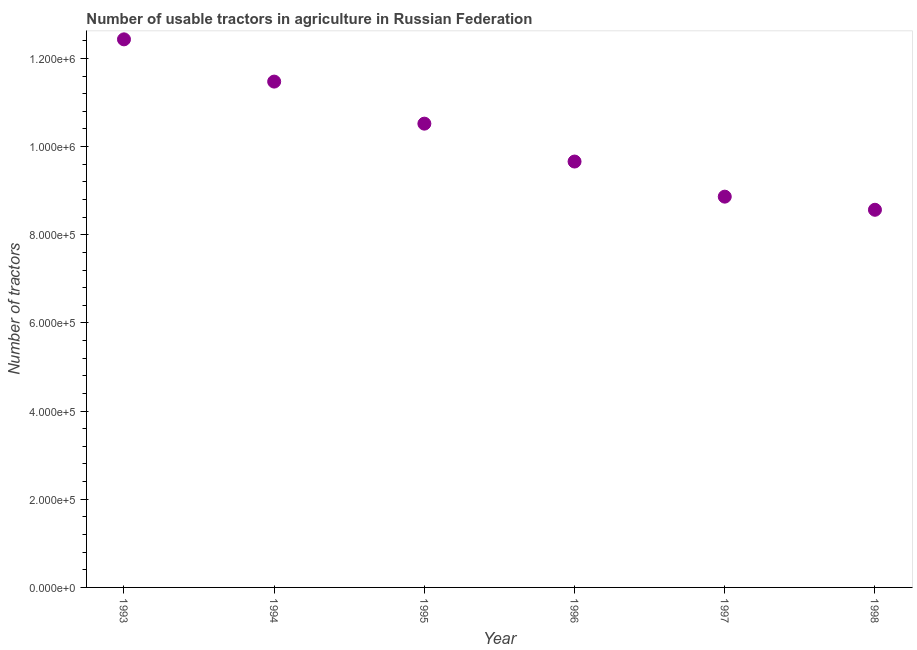What is the number of tractors in 1998?
Provide a short and direct response. 8.57e+05. Across all years, what is the maximum number of tractors?
Make the answer very short. 1.24e+06. Across all years, what is the minimum number of tractors?
Your answer should be compact. 8.57e+05. In which year was the number of tractors maximum?
Your answer should be compact. 1993. What is the sum of the number of tractors?
Your answer should be compact. 6.15e+06. What is the difference between the number of tractors in 1994 and 1997?
Ensure brevity in your answer.  2.61e+05. What is the average number of tractors per year?
Offer a very short reply. 1.03e+06. What is the median number of tractors?
Offer a terse response. 1.01e+06. Do a majority of the years between 1996 and 1998 (inclusive) have number of tractors greater than 480000 ?
Keep it short and to the point. Yes. What is the ratio of the number of tractors in 1993 to that in 1995?
Provide a short and direct response. 1.18. What is the difference between the highest and the second highest number of tractors?
Offer a terse response. 9.58e+04. What is the difference between the highest and the lowest number of tractors?
Offer a terse response. 3.87e+05. Does the number of tractors monotonically increase over the years?
Ensure brevity in your answer.  No. How many dotlines are there?
Your response must be concise. 1. How many years are there in the graph?
Give a very brief answer. 6. What is the difference between two consecutive major ticks on the Y-axis?
Offer a very short reply. 2.00e+05. What is the title of the graph?
Give a very brief answer. Number of usable tractors in agriculture in Russian Federation. What is the label or title of the X-axis?
Your response must be concise. Year. What is the label or title of the Y-axis?
Offer a very short reply. Number of tractors. What is the Number of tractors in 1993?
Provide a short and direct response. 1.24e+06. What is the Number of tractors in 1994?
Your response must be concise. 1.15e+06. What is the Number of tractors in 1995?
Offer a very short reply. 1.05e+06. What is the Number of tractors in 1996?
Give a very brief answer. 9.66e+05. What is the Number of tractors in 1997?
Your answer should be compact. 8.86e+05. What is the Number of tractors in 1998?
Provide a succinct answer. 8.57e+05. What is the difference between the Number of tractors in 1993 and 1994?
Provide a succinct answer. 9.58e+04. What is the difference between the Number of tractors in 1993 and 1995?
Make the answer very short. 1.91e+05. What is the difference between the Number of tractors in 1993 and 1996?
Your answer should be very brief. 2.77e+05. What is the difference between the Number of tractors in 1993 and 1997?
Your answer should be compact. 3.57e+05. What is the difference between the Number of tractors in 1993 and 1998?
Your answer should be compact. 3.87e+05. What is the difference between the Number of tractors in 1994 and 1995?
Make the answer very short. 9.54e+04. What is the difference between the Number of tractors in 1994 and 1996?
Your response must be concise. 1.81e+05. What is the difference between the Number of tractors in 1994 and 1997?
Your response must be concise. 2.61e+05. What is the difference between the Number of tractors in 1994 and 1998?
Make the answer very short. 2.91e+05. What is the difference between the Number of tractors in 1995 and 1996?
Your response must be concise. 8.60e+04. What is the difference between the Number of tractors in 1995 and 1997?
Provide a succinct answer. 1.66e+05. What is the difference between the Number of tractors in 1995 and 1998?
Your response must be concise. 1.95e+05. What is the difference between the Number of tractors in 1996 and 1997?
Your answer should be very brief. 7.96e+04. What is the difference between the Number of tractors in 1996 and 1998?
Your response must be concise. 1.09e+05. What is the difference between the Number of tractors in 1997 and 1998?
Make the answer very short. 2.98e+04. What is the ratio of the Number of tractors in 1993 to that in 1994?
Offer a terse response. 1.08. What is the ratio of the Number of tractors in 1993 to that in 1995?
Offer a very short reply. 1.18. What is the ratio of the Number of tractors in 1993 to that in 1996?
Keep it short and to the point. 1.29. What is the ratio of the Number of tractors in 1993 to that in 1997?
Ensure brevity in your answer.  1.4. What is the ratio of the Number of tractors in 1993 to that in 1998?
Offer a terse response. 1.45. What is the ratio of the Number of tractors in 1994 to that in 1995?
Give a very brief answer. 1.09. What is the ratio of the Number of tractors in 1994 to that in 1996?
Your response must be concise. 1.19. What is the ratio of the Number of tractors in 1994 to that in 1997?
Give a very brief answer. 1.29. What is the ratio of the Number of tractors in 1994 to that in 1998?
Ensure brevity in your answer.  1.34. What is the ratio of the Number of tractors in 1995 to that in 1996?
Provide a succinct answer. 1.09. What is the ratio of the Number of tractors in 1995 to that in 1997?
Keep it short and to the point. 1.19. What is the ratio of the Number of tractors in 1995 to that in 1998?
Offer a terse response. 1.23. What is the ratio of the Number of tractors in 1996 to that in 1997?
Give a very brief answer. 1.09. What is the ratio of the Number of tractors in 1996 to that in 1998?
Your response must be concise. 1.13. What is the ratio of the Number of tractors in 1997 to that in 1998?
Give a very brief answer. 1.03. 